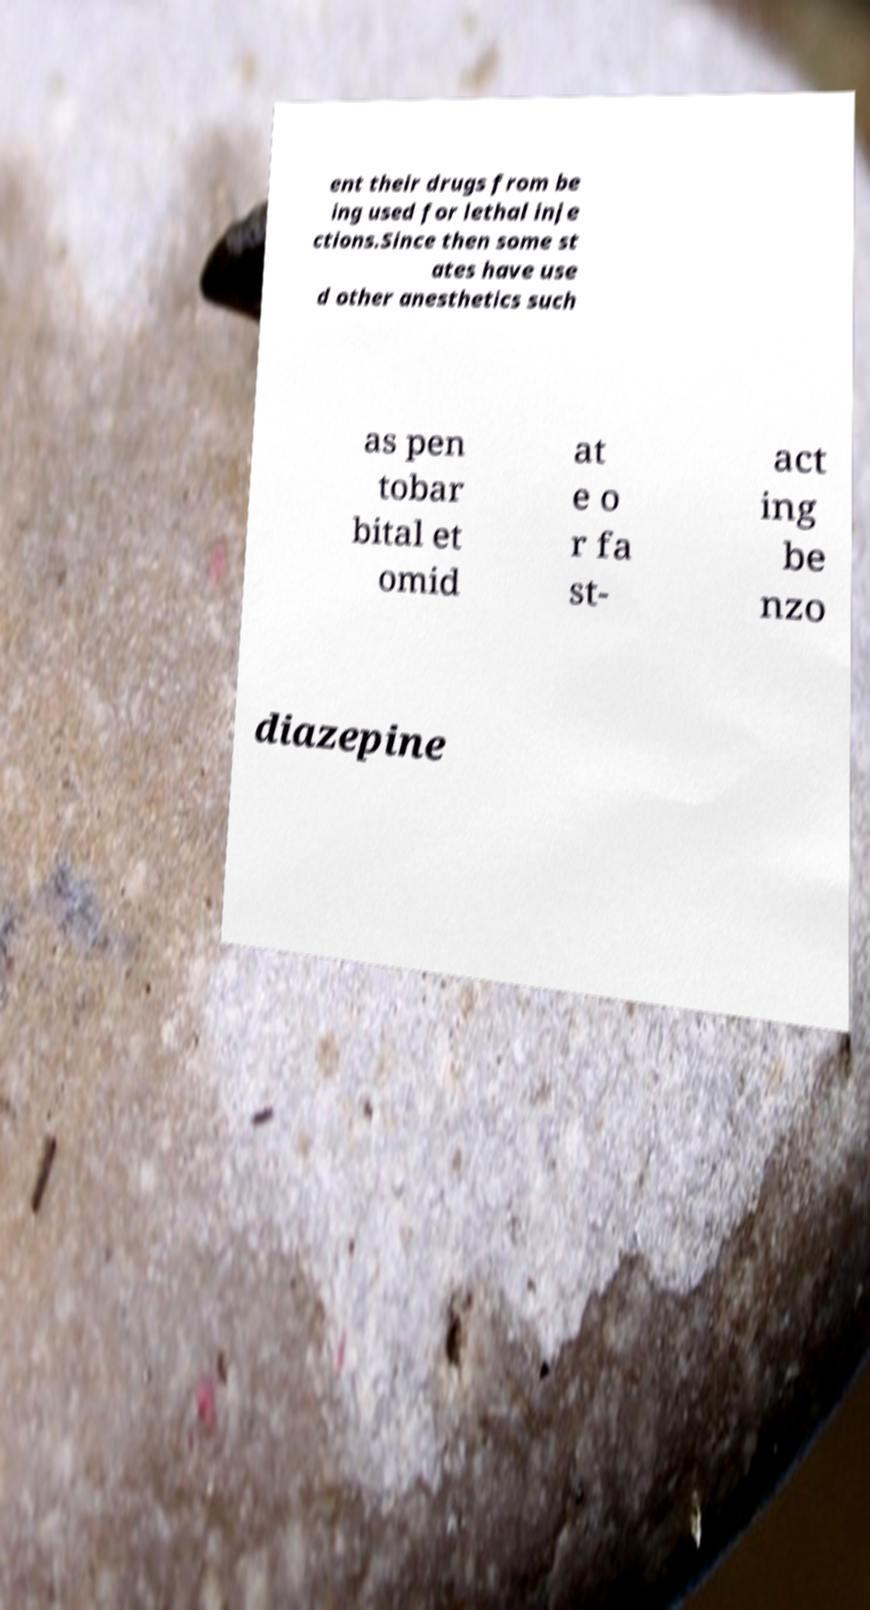I need the written content from this picture converted into text. Can you do that? ent their drugs from be ing used for lethal inje ctions.Since then some st ates have use d other anesthetics such as pen tobar bital et omid at e o r fa st- act ing be nzo diazepine 